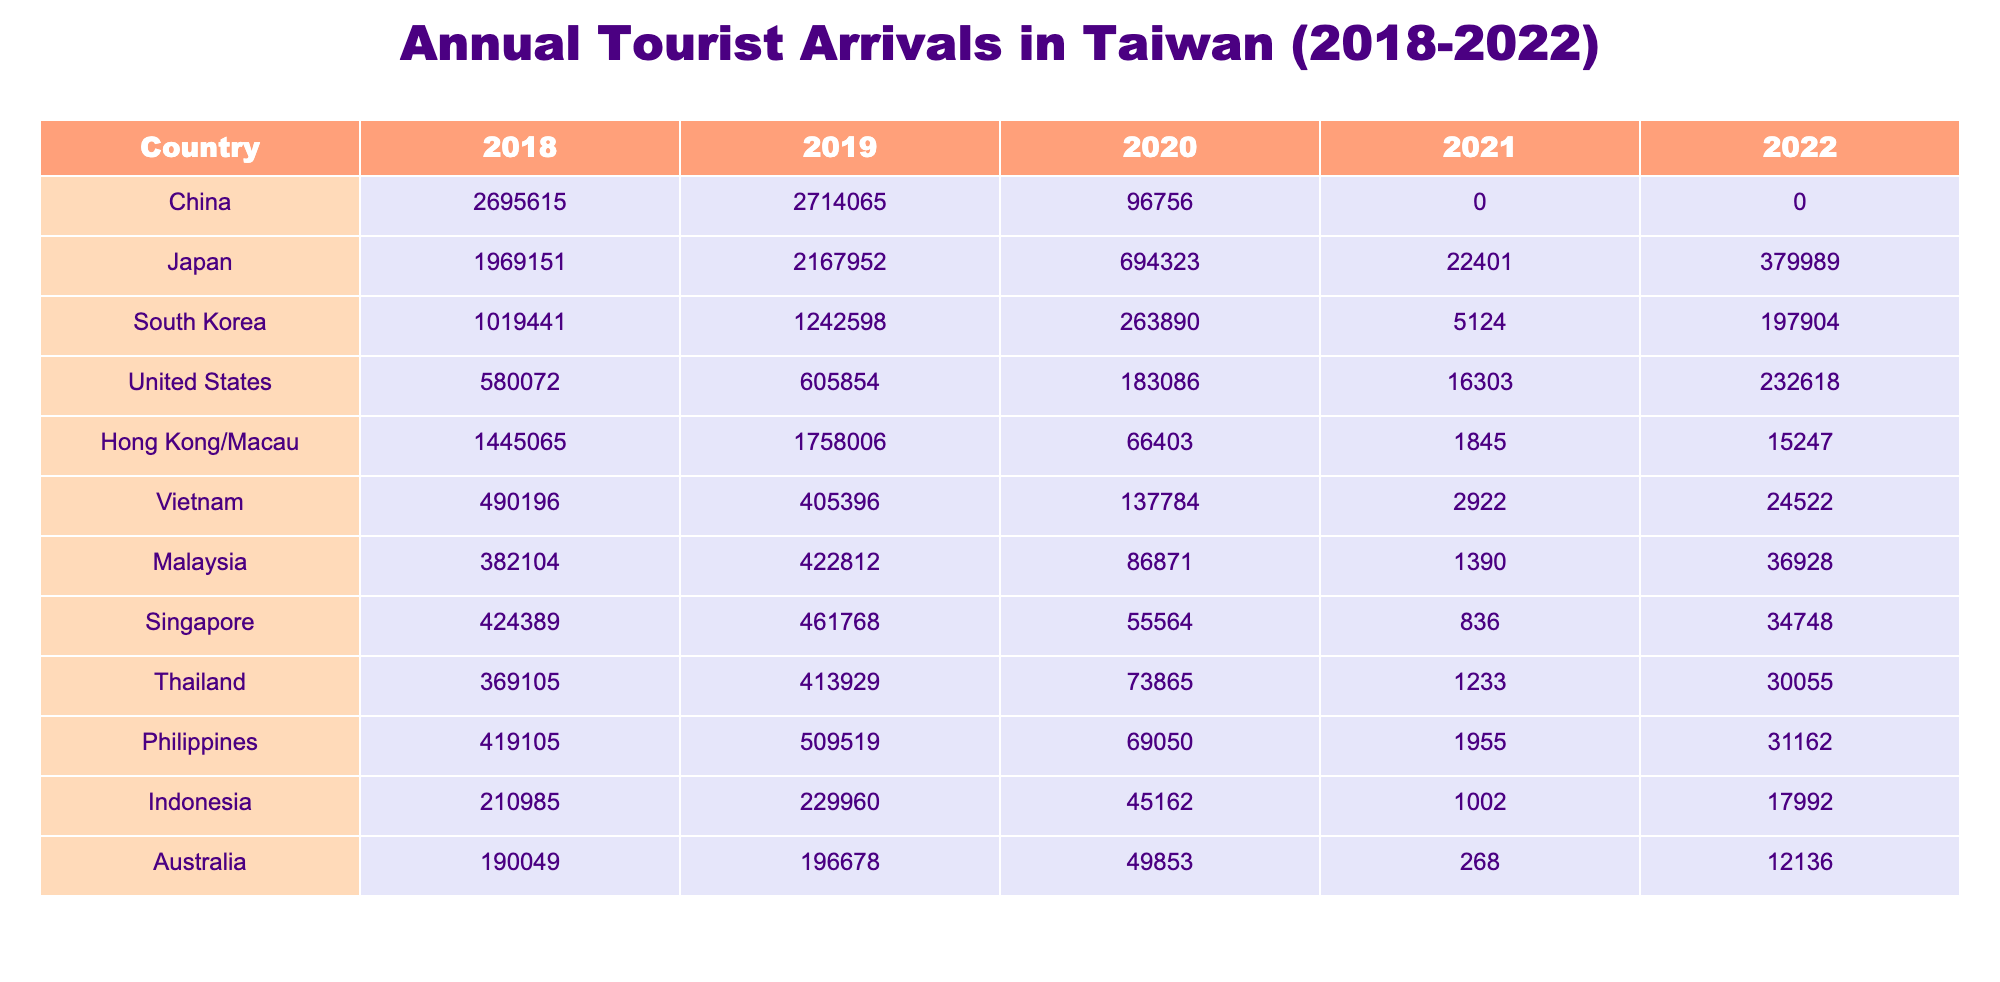What was the highest number of tourist arrivals from South Korea in the years 2018-2022? The highest number of tourist arrivals from South Korea was in 2019, with 1,242,598 visitors. This is found by looking at the values under the South Korea column for each year.
Answer: 1,242,598 Which country had the most significant decline in tourist arrivals from 2019 to 2021? To determine this, we compare each country's arrivals from 2019 to 2021. China saw a decline from 2,714,065 in 2019 to 0 in 2021, which is a decrease of 2,714,065. Therefore, China had the most significant decline.
Answer: China What was the total number of tourists from Japan in the years 2018-2022? The total number of tourists from Japan is calculated by summing the values for each year: 1,969,151 (2018) + 2,167,952 (2019) + 694,323 (2020) + 22,401 (2021) + 379,989 (2022) = 5,233,816.
Answer: 5,233,816 Did the United States have more tourist arrivals in 2022 compared to 2020? In 2020, the number of arrivals from the United States was 183,086, while in 2022 it was 232,618. Since 232,618 is greater than 183,086, it confirms that yes, the United States had more arrivals in 2022 than in 2020.
Answer: Yes What was the average number of tourists from China and Hong Kong/Macau over the years? To find the average, first sum the total arrivals for China (2,695,615 + 2,714,065 + 96,756 + 0 + 0 = 5,506,436) and Hong Kong/Macau (1,445,065 + 1,758,006 + 66,403 + 1,845 + 15,247 = 3,286,566). Then, divide the total by the number of years (5 years), which is (5,506,436 + 3,286,566) / 5 = 1,958,200.4.
Answer: 1,958,200.4 Which country shows a consistent decline in tourist arrivals from 2018 to 2021? By examining each country's annual data, we see that China experienced a consistent decline from 2018 to 2021, going from 2,695,615 (2018) to 0 (2021). Thus, China is the country that shows a consistent decline.
Answer: China 